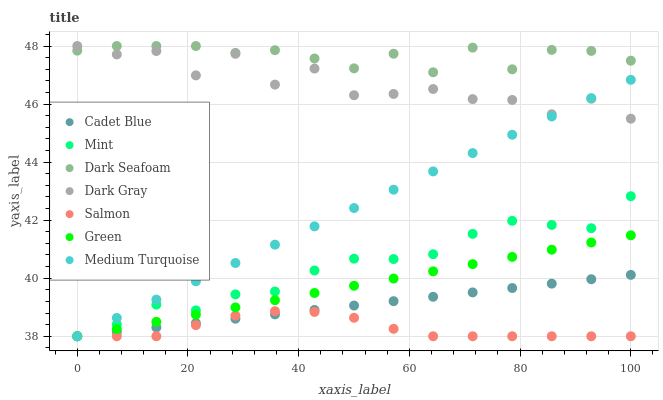Does Salmon have the minimum area under the curve?
Answer yes or no. Yes. Does Dark Seafoam have the maximum area under the curve?
Answer yes or no. Yes. Does Dark Gray have the minimum area under the curve?
Answer yes or no. No. Does Dark Gray have the maximum area under the curve?
Answer yes or no. No. Is Cadet Blue the smoothest?
Answer yes or no. Yes. Is Dark Gray the roughest?
Answer yes or no. Yes. Is Salmon the smoothest?
Answer yes or no. No. Is Salmon the roughest?
Answer yes or no. No. Does Cadet Blue have the lowest value?
Answer yes or no. Yes. Does Dark Gray have the lowest value?
Answer yes or no. No. Does Dark Seafoam have the highest value?
Answer yes or no. Yes. Does Salmon have the highest value?
Answer yes or no. No. Is Cadet Blue less than Dark Gray?
Answer yes or no. Yes. Is Dark Seafoam greater than Salmon?
Answer yes or no. Yes. Does Green intersect Cadet Blue?
Answer yes or no. Yes. Is Green less than Cadet Blue?
Answer yes or no. No. Is Green greater than Cadet Blue?
Answer yes or no. No. Does Cadet Blue intersect Dark Gray?
Answer yes or no. No. 